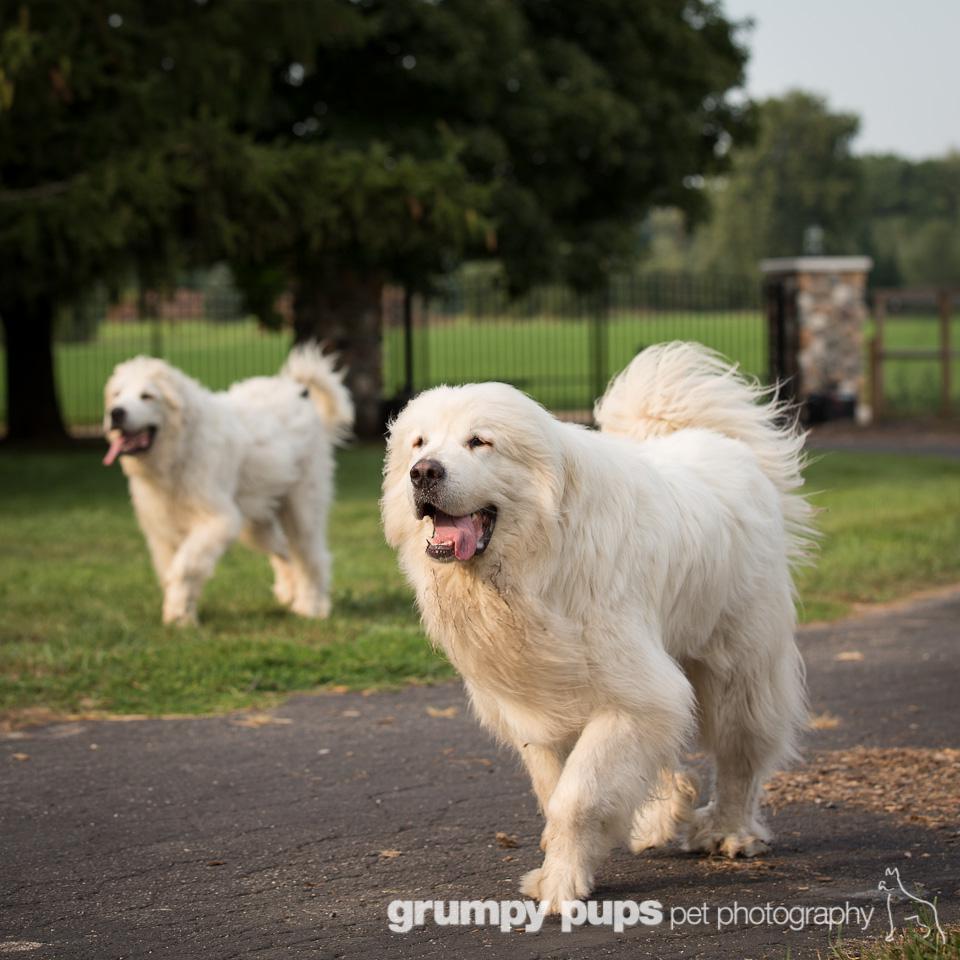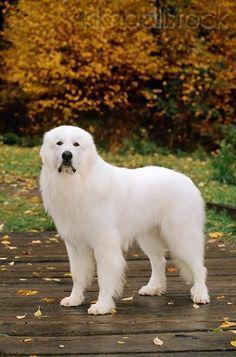The first image is the image on the left, the second image is the image on the right. For the images shown, is this caption "the right pic has two or more dogs" true? Answer yes or no. No. The first image is the image on the left, the second image is the image on the right. Considering the images on both sides, is "In at least one image there are exactly two dogs that are seated close together." valid? Answer yes or no. No. 